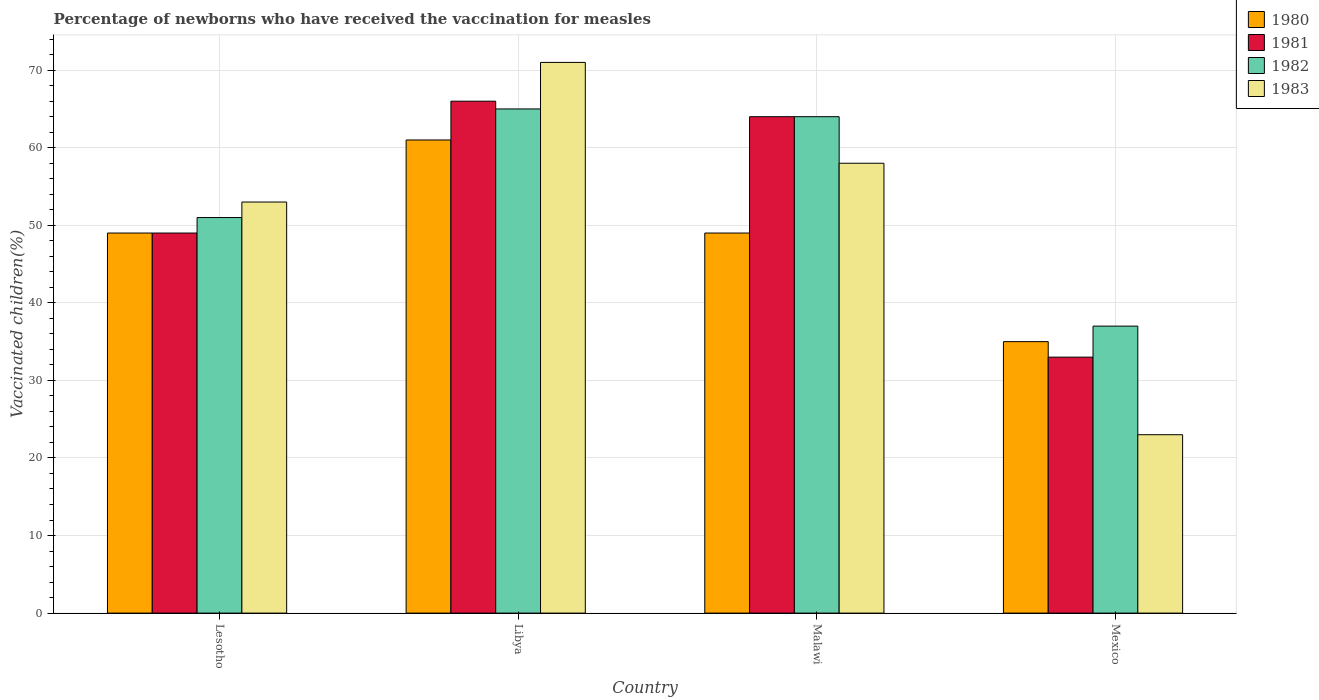How many different coloured bars are there?
Offer a very short reply. 4. How many groups of bars are there?
Give a very brief answer. 4. Are the number of bars per tick equal to the number of legend labels?
Provide a short and direct response. Yes. Are the number of bars on each tick of the X-axis equal?
Your response must be concise. Yes. How many bars are there on the 4th tick from the right?
Provide a succinct answer. 4. What is the label of the 2nd group of bars from the left?
Your answer should be compact. Libya. What is the percentage of vaccinated children in 1981 in Lesotho?
Offer a terse response. 49. Across all countries, what is the minimum percentage of vaccinated children in 1981?
Ensure brevity in your answer.  33. In which country was the percentage of vaccinated children in 1981 maximum?
Offer a terse response. Libya. What is the total percentage of vaccinated children in 1981 in the graph?
Give a very brief answer. 212. What is the difference between the percentage of vaccinated children in 1981 in Malawi and that in Mexico?
Provide a short and direct response. 31. What is the average percentage of vaccinated children in 1982 per country?
Offer a terse response. 54.25. What is the difference between the percentage of vaccinated children of/in 1983 and percentage of vaccinated children of/in 1982 in Libya?
Keep it short and to the point. 6. In how many countries, is the percentage of vaccinated children in 1980 greater than 38 %?
Keep it short and to the point. 3. What is the ratio of the percentage of vaccinated children in 1980 in Lesotho to that in Mexico?
Keep it short and to the point. 1.4. What is the difference between the highest and the lowest percentage of vaccinated children in 1980?
Make the answer very short. 26. What does the 4th bar from the left in Malawi represents?
Give a very brief answer. 1983. Is it the case that in every country, the sum of the percentage of vaccinated children in 1980 and percentage of vaccinated children in 1982 is greater than the percentage of vaccinated children in 1981?
Offer a very short reply. Yes. How are the legend labels stacked?
Ensure brevity in your answer.  Vertical. What is the title of the graph?
Give a very brief answer. Percentage of newborns who have received the vaccination for measles. What is the label or title of the X-axis?
Your answer should be compact. Country. What is the label or title of the Y-axis?
Your answer should be compact. Vaccinated children(%). What is the Vaccinated children(%) in 1980 in Lesotho?
Offer a terse response. 49. What is the Vaccinated children(%) of 1981 in Lesotho?
Your response must be concise. 49. What is the Vaccinated children(%) in 1980 in Libya?
Your answer should be compact. 61. What is the Vaccinated children(%) of 1982 in Libya?
Keep it short and to the point. 65. What is the Vaccinated children(%) of 1981 in Malawi?
Provide a short and direct response. 64. What is the Vaccinated children(%) of 1982 in Malawi?
Offer a very short reply. 64. What is the Vaccinated children(%) in 1983 in Malawi?
Make the answer very short. 58. What is the Vaccinated children(%) in 1980 in Mexico?
Provide a succinct answer. 35. Across all countries, what is the maximum Vaccinated children(%) of 1980?
Keep it short and to the point. 61. Across all countries, what is the maximum Vaccinated children(%) of 1983?
Your response must be concise. 71. Across all countries, what is the minimum Vaccinated children(%) in 1980?
Offer a terse response. 35. Across all countries, what is the minimum Vaccinated children(%) in 1981?
Provide a short and direct response. 33. Across all countries, what is the minimum Vaccinated children(%) in 1982?
Ensure brevity in your answer.  37. Across all countries, what is the minimum Vaccinated children(%) in 1983?
Your answer should be compact. 23. What is the total Vaccinated children(%) in 1980 in the graph?
Provide a short and direct response. 194. What is the total Vaccinated children(%) in 1981 in the graph?
Provide a short and direct response. 212. What is the total Vaccinated children(%) of 1982 in the graph?
Your answer should be compact. 217. What is the total Vaccinated children(%) of 1983 in the graph?
Your answer should be very brief. 205. What is the difference between the Vaccinated children(%) of 1981 in Lesotho and that in Libya?
Your answer should be compact. -17. What is the difference between the Vaccinated children(%) in 1982 in Lesotho and that in Libya?
Offer a terse response. -14. What is the difference between the Vaccinated children(%) of 1980 in Lesotho and that in Malawi?
Offer a very short reply. 0. What is the difference between the Vaccinated children(%) of 1981 in Lesotho and that in Malawi?
Offer a very short reply. -15. What is the difference between the Vaccinated children(%) in 1982 in Lesotho and that in Malawi?
Ensure brevity in your answer.  -13. What is the difference between the Vaccinated children(%) in 1983 in Lesotho and that in Malawi?
Keep it short and to the point. -5. What is the difference between the Vaccinated children(%) of 1983 in Lesotho and that in Mexico?
Your answer should be compact. 30. What is the difference between the Vaccinated children(%) in 1980 in Libya and that in Malawi?
Keep it short and to the point. 12. What is the difference between the Vaccinated children(%) in 1981 in Libya and that in Malawi?
Provide a short and direct response. 2. What is the difference between the Vaccinated children(%) of 1983 in Libya and that in Malawi?
Offer a terse response. 13. What is the difference between the Vaccinated children(%) of 1980 in Libya and that in Mexico?
Provide a short and direct response. 26. What is the difference between the Vaccinated children(%) in 1981 in Libya and that in Mexico?
Your answer should be very brief. 33. What is the difference between the Vaccinated children(%) in 1980 in Malawi and that in Mexico?
Provide a short and direct response. 14. What is the difference between the Vaccinated children(%) in 1981 in Malawi and that in Mexico?
Your response must be concise. 31. What is the difference between the Vaccinated children(%) of 1983 in Malawi and that in Mexico?
Your response must be concise. 35. What is the difference between the Vaccinated children(%) in 1980 in Lesotho and the Vaccinated children(%) in 1982 in Libya?
Offer a very short reply. -16. What is the difference between the Vaccinated children(%) in 1980 in Lesotho and the Vaccinated children(%) in 1983 in Libya?
Ensure brevity in your answer.  -22. What is the difference between the Vaccinated children(%) of 1981 in Lesotho and the Vaccinated children(%) of 1982 in Libya?
Offer a very short reply. -16. What is the difference between the Vaccinated children(%) in 1980 in Lesotho and the Vaccinated children(%) in 1981 in Malawi?
Keep it short and to the point. -15. What is the difference between the Vaccinated children(%) of 1980 in Lesotho and the Vaccinated children(%) of 1982 in Malawi?
Give a very brief answer. -15. What is the difference between the Vaccinated children(%) of 1981 in Lesotho and the Vaccinated children(%) of 1982 in Malawi?
Offer a very short reply. -15. What is the difference between the Vaccinated children(%) in 1981 in Lesotho and the Vaccinated children(%) in 1983 in Malawi?
Your answer should be very brief. -9. What is the difference between the Vaccinated children(%) in 1982 in Lesotho and the Vaccinated children(%) in 1983 in Malawi?
Provide a short and direct response. -7. What is the difference between the Vaccinated children(%) in 1980 in Lesotho and the Vaccinated children(%) in 1981 in Mexico?
Make the answer very short. 16. What is the difference between the Vaccinated children(%) of 1980 in Lesotho and the Vaccinated children(%) of 1983 in Mexico?
Ensure brevity in your answer.  26. What is the difference between the Vaccinated children(%) of 1981 in Lesotho and the Vaccinated children(%) of 1982 in Mexico?
Offer a terse response. 12. What is the difference between the Vaccinated children(%) in 1981 in Lesotho and the Vaccinated children(%) in 1983 in Mexico?
Offer a very short reply. 26. What is the difference between the Vaccinated children(%) of 1980 in Libya and the Vaccinated children(%) of 1981 in Malawi?
Provide a short and direct response. -3. What is the difference between the Vaccinated children(%) of 1980 in Libya and the Vaccinated children(%) of 1983 in Malawi?
Provide a short and direct response. 3. What is the difference between the Vaccinated children(%) of 1980 in Libya and the Vaccinated children(%) of 1981 in Mexico?
Your answer should be very brief. 28. What is the difference between the Vaccinated children(%) in 1981 in Libya and the Vaccinated children(%) in 1982 in Mexico?
Your answer should be very brief. 29. What is the difference between the Vaccinated children(%) of 1982 in Libya and the Vaccinated children(%) of 1983 in Mexico?
Provide a succinct answer. 42. What is the difference between the Vaccinated children(%) of 1980 in Malawi and the Vaccinated children(%) of 1982 in Mexico?
Keep it short and to the point. 12. What is the difference between the Vaccinated children(%) in 1981 in Malawi and the Vaccinated children(%) in 1982 in Mexico?
Give a very brief answer. 27. What is the difference between the Vaccinated children(%) of 1981 in Malawi and the Vaccinated children(%) of 1983 in Mexico?
Offer a very short reply. 41. What is the average Vaccinated children(%) of 1980 per country?
Provide a short and direct response. 48.5. What is the average Vaccinated children(%) of 1981 per country?
Offer a terse response. 53. What is the average Vaccinated children(%) in 1982 per country?
Your answer should be very brief. 54.25. What is the average Vaccinated children(%) in 1983 per country?
Provide a short and direct response. 51.25. What is the difference between the Vaccinated children(%) in 1980 and Vaccinated children(%) in 1981 in Lesotho?
Keep it short and to the point. 0. What is the difference between the Vaccinated children(%) in 1981 and Vaccinated children(%) in 1982 in Lesotho?
Provide a short and direct response. -2. What is the difference between the Vaccinated children(%) of 1981 and Vaccinated children(%) of 1983 in Lesotho?
Offer a very short reply. -4. What is the difference between the Vaccinated children(%) of 1982 and Vaccinated children(%) of 1983 in Lesotho?
Give a very brief answer. -2. What is the difference between the Vaccinated children(%) in 1980 and Vaccinated children(%) in 1981 in Libya?
Your answer should be compact. -5. What is the difference between the Vaccinated children(%) in 1980 and Vaccinated children(%) in 1982 in Libya?
Keep it short and to the point. -4. What is the difference between the Vaccinated children(%) in 1981 and Vaccinated children(%) in 1983 in Libya?
Your answer should be very brief. -5. What is the difference between the Vaccinated children(%) of 1982 and Vaccinated children(%) of 1983 in Libya?
Your answer should be very brief. -6. What is the difference between the Vaccinated children(%) of 1980 and Vaccinated children(%) of 1981 in Malawi?
Offer a very short reply. -15. What is the difference between the Vaccinated children(%) in 1982 and Vaccinated children(%) in 1983 in Malawi?
Offer a terse response. 6. What is the difference between the Vaccinated children(%) of 1980 and Vaccinated children(%) of 1981 in Mexico?
Your answer should be very brief. 2. What is the difference between the Vaccinated children(%) in 1980 and Vaccinated children(%) in 1983 in Mexico?
Your response must be concise. 12. What is the difference between the Vaccinated children(%) in 1981 and Vaccinated children(%) in 1983 in Mexico?
Give a very brief answer. 10. What is the difference between the Vaccinated children(%) in 1982 and Vaccinated children(%) in 1983 in Mexico?
Provide a short and direct response. 14. What is the ratio of the Vaccinated children(%) of 1980 in Lesotho to that in Libya?
Ensure brevity in your answer.  0.8. What is the ratio of the Vaccinated children(%) of 1981 in Lesotho to that in Libya?
Your answer should be very brief. 0.74. What is the ratio of the Vaccinated children(%) in 1982 in Lesotho to that in Libya?
Your answer should be very brief. 0.78. What is the ratio of the Vaccinated children(%) in 1983 in Lesotho to that in Libya?
Offer a very short reply. 0.75. What is the ratio of the Vaccinated children(%) of 1981 in Lesotho to that in Malawi?
Give a very brief answer. 0.77. What is the ratio of the Vaccinated children(%) of 1982 in Lesotho to that in Malawi?
Your answer should be compact. 0.8. What is the ratio of the Vaccinated children(%) in 1983 in Lesotho to that in Malawi?
Give a very brief answer. 0.91. What is the ratio of the Vaccinated children(%) in 1980 in Lesotho to that in Mexico?
Give a very brief answer. 1.4. What is the ratio of the Vaccinated children(%) in 1981 in Lesotho to that in Mexico?
Provide a succinct answer. 1.48. What is the ratio of the Vaccinated children(%) in 1982 in Lesotho to that in Mexico?
Your answer should be compact. 1.38. What is the ratio of the Vaccinated children(%) of 1983 in Lesotho to that in Mexico?
Provide a succinct answer. 2.3. What is the ratio of the Vaccinated children(%) of 1980 in Libya to that in Malawi?
Offer a terse response. 1.24. What is the ratio of the Vaccinated children(%) in 1981 in Libya to that in Malawi?
Offer a very short reply. 1.03. What is the ratio of the Vaccinated children(%) in 1982 in Libya to that in Malawi?
Ensure brevity in your answer.  1.02. What is the ratio of the Vaccinated children(%) of 1983 in Libya to that in Malawi?
Offer a terse response. 1.22. What is the ratio of the Vaccinated children(%) of 1980 in Libya to that in Mexico?
Your answer should be very brief. 1.74. What is the ratio of the Vaccinated children(%) in 1981 in Libya to that in Mexico?
Your response must be concise. 2. What is the ratio of the Vaccinated children(%) in 1982 in Libya to that in Mexico?
Offer a terse response. 1.76. What is the ratio of the Vaccinated children(%) of 1983 in Libya to that in Mexico?
Offer a very short reply. 3.09. What is the ratio of the Vaccinated children(%) of 1981 in Malawi to that in Mexico?
Your answer should be very brief. 1.94. What is the ratio of the Vaccinated children(%) in 1982 in Malawi to that in Mexico?
Your answer should be very brief. 1.73. What is the ratio of the Vaccinated children(%) of 1983 in Malawi to that in Mexico?
Give a very brief answer. 2.52. What is the difference between the highest and the second highest Vaccinated children(%) in 1980?
Offer a terse response. 12. What is the difference between the highest and the second highest Vaccinated children(%) of 1983?
Your answer should be compact. 13. What is the difference between the highest and the lowest Vaccinated children(%) in 1981?
Your answer should be very brief. 33. What is the difference between the highest and the lowest Vaccinated children(%) in 1983?
Your answer should be very brief. 48. 